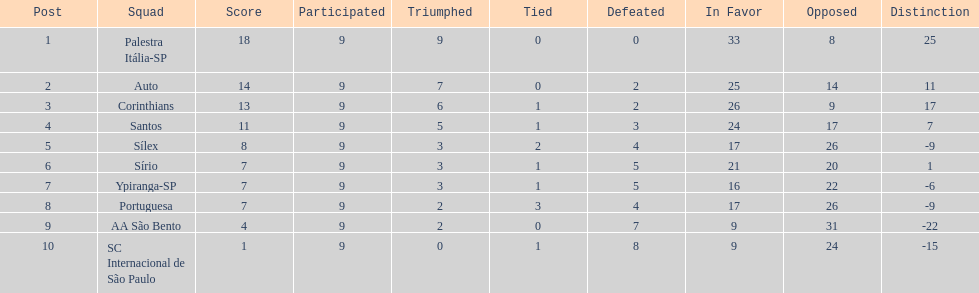Which is the only team to score 13 points in 9 games? Corinthians. 